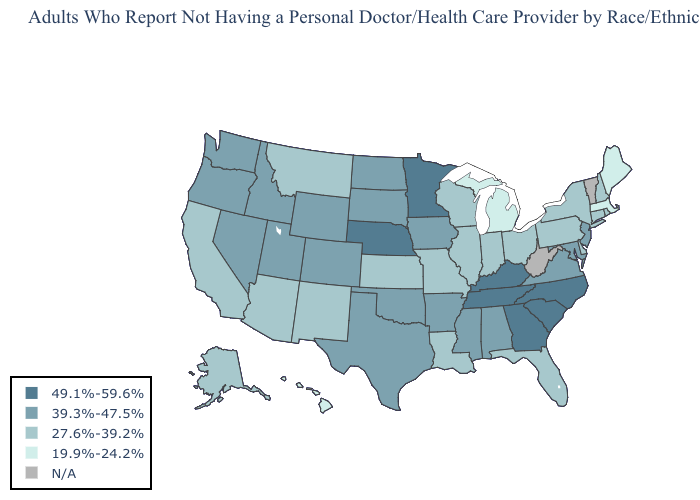Name the states that have a value in the range N/A?
Concise answer only. Vermont, West Virginia. Does Washington have the highest value in the West?
Short answer required. Yes. Which states hav the highest value in the Northeast?
Answer briefly. New Jersey. Name the states that have a value in the range 49.1%-59.6%?
Give a very brief answer. Georgia, Kentucky, Minnesota, Nebraska, North Carolina, South Carolina, Tennessee. Name the states that have a value in the range 39.3%-47.5%?
Answer briefly. Alabama, Arkansas, Colorado, Idaho, Iowa, Maryland, Mississippi, Nevada, New Jersey, North Dakota, Oklahoma, Oregon, South Dakota, Texas, Utah, Virginia, Washington, Wyoming. Name the states that have a value in the range 19.9%-24.2%?
Write a very short answer. Hawaii, Maine, Massachusetts, Michigan. What is the lowest value in the West?
Short answer required. 19.9%-24.2%. Among the states that border Mississippi , which have the lowest value?
Concise answer only. Louisiana. What is the value of California?
Keep it brief. 27.6%-39.2%. What is the value of Washington?
Write a very short answer. 39.3%-47.5%. What is the lowest value in the USA?
Be succinct. 19.9%-24.2%. What is the lowest value in the USA?
Short answer required. 19.9%-24.2%. Name the states that have a value in the range 19.9%-24.2%?
Short answer required. Hawaii, Maine, Massachusetts, Michigan. How many symbols are there in the legend?
Be succinct. 5. 